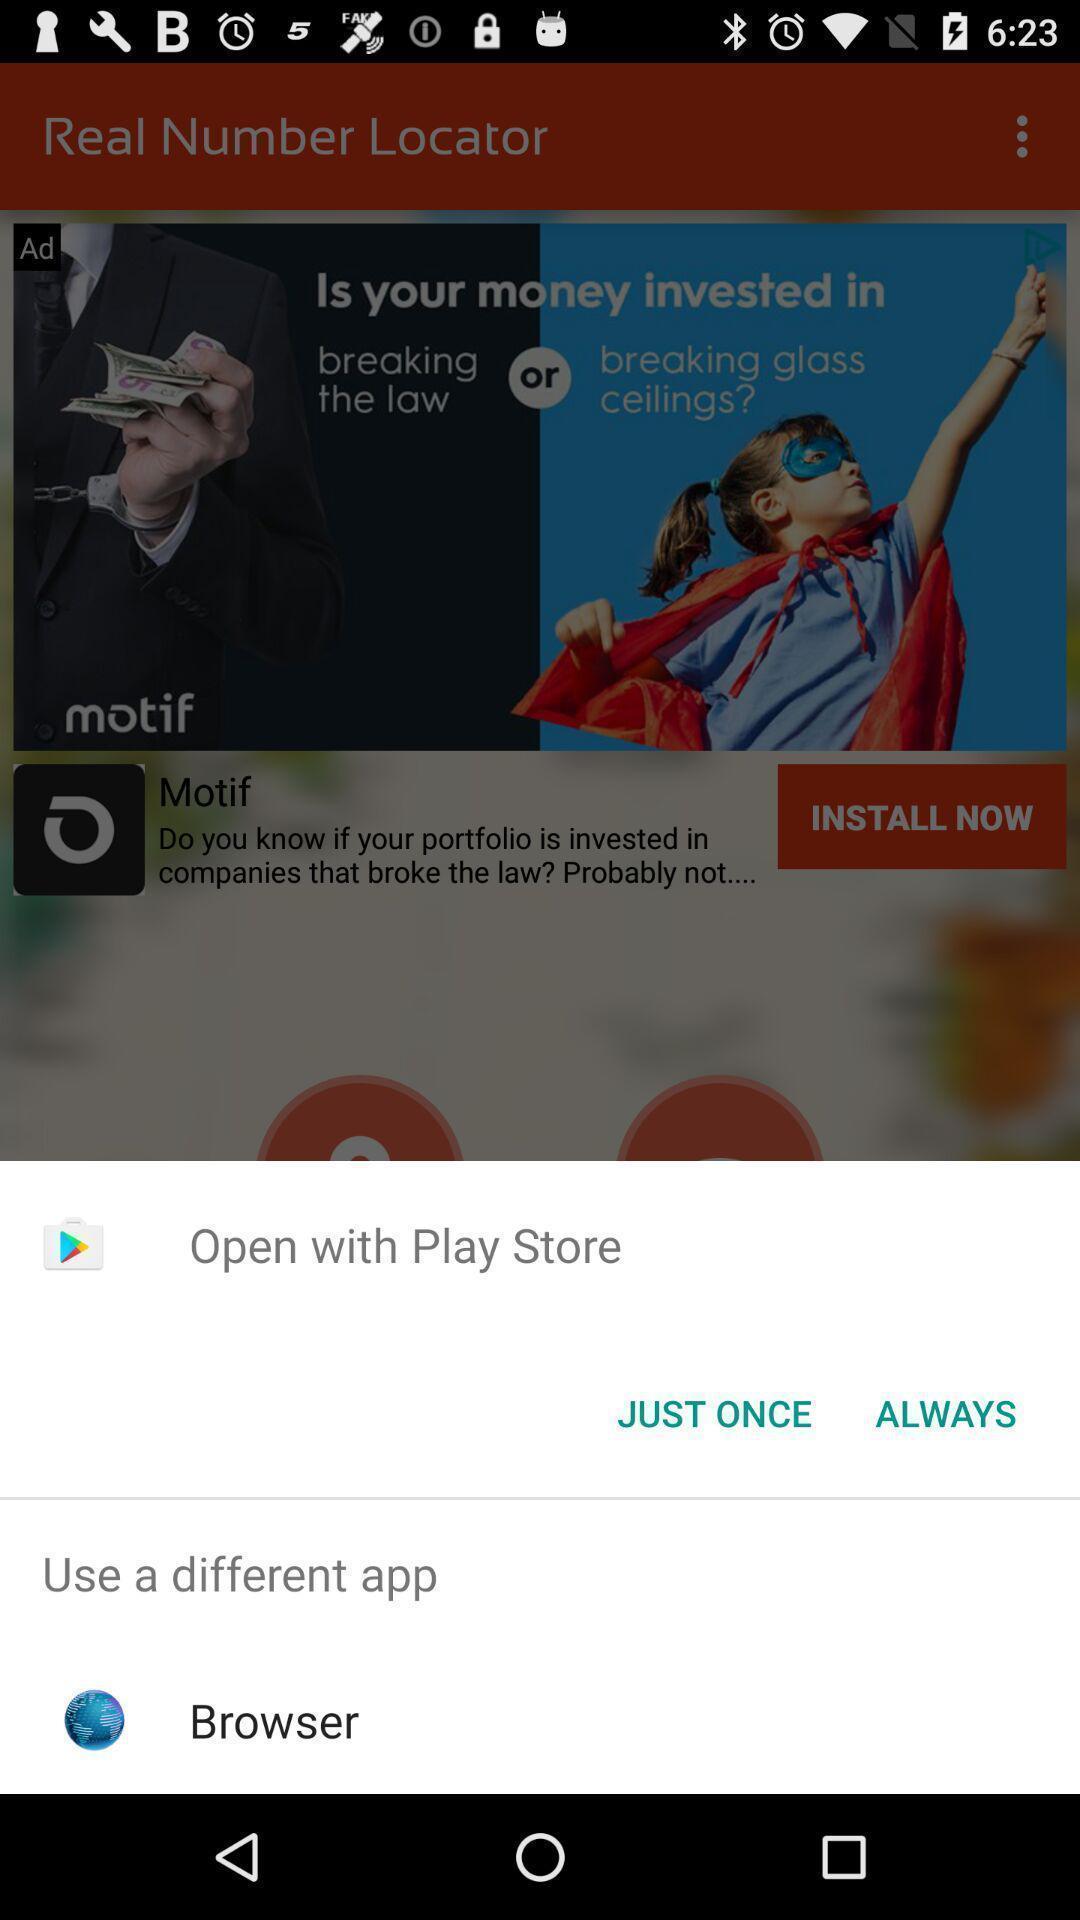What details can you identify in this image? Push-up displaying to open the page. 